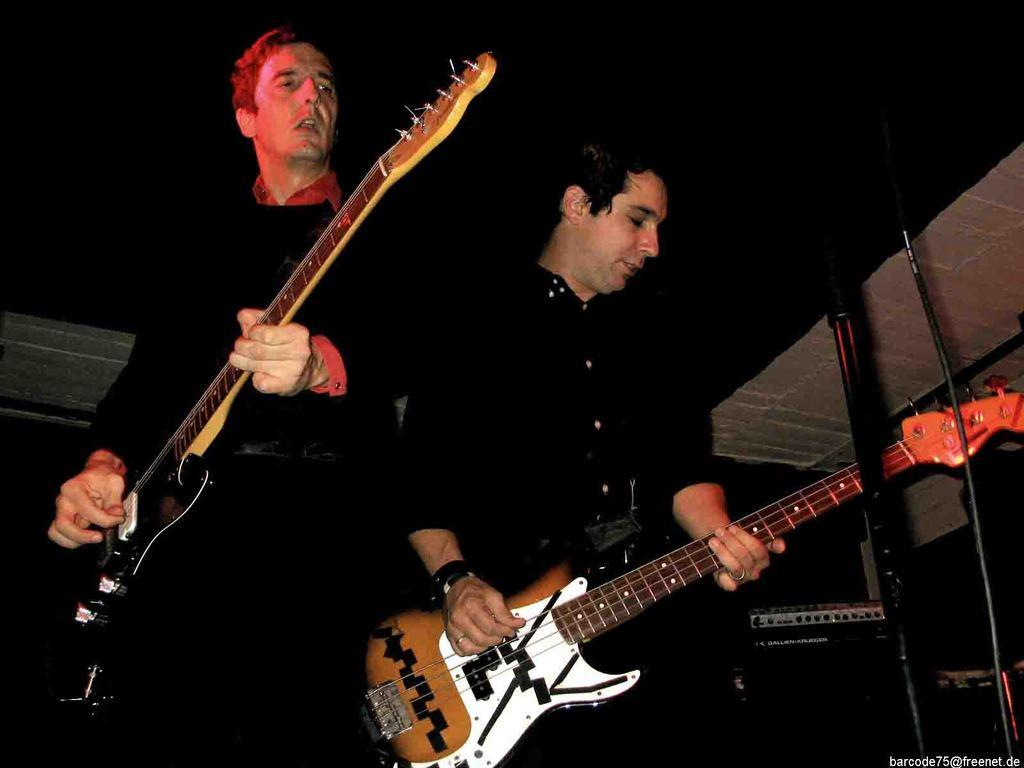How many people are present in the image? There are two people in the image. What are the people wearing? Both people are wearing black dresses. What activity are the people engaged in? The two people are playing guitar. What type of mark can be seen on the guitar strings in the image? There is no mention of any marks on the guitar strings in the image. 